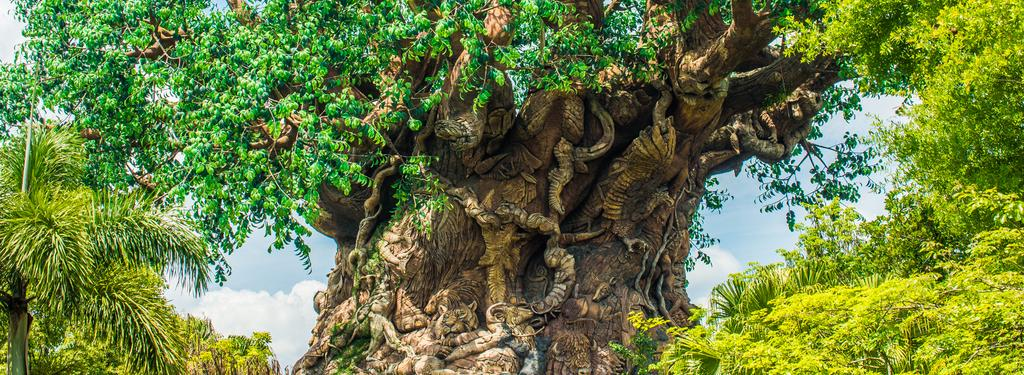What type of vegetation can be seen in the image? There are trees in the image. What part of the natural environment is visible in the image? The sky is visible in the background of the image. What type of curtain can be seen hanging from the trees in the image? There are no curtains present in the image; it features trees and the sky. Can you tell me when the bear gave birth in the image? There are no bears or any indication of birth in the image. 